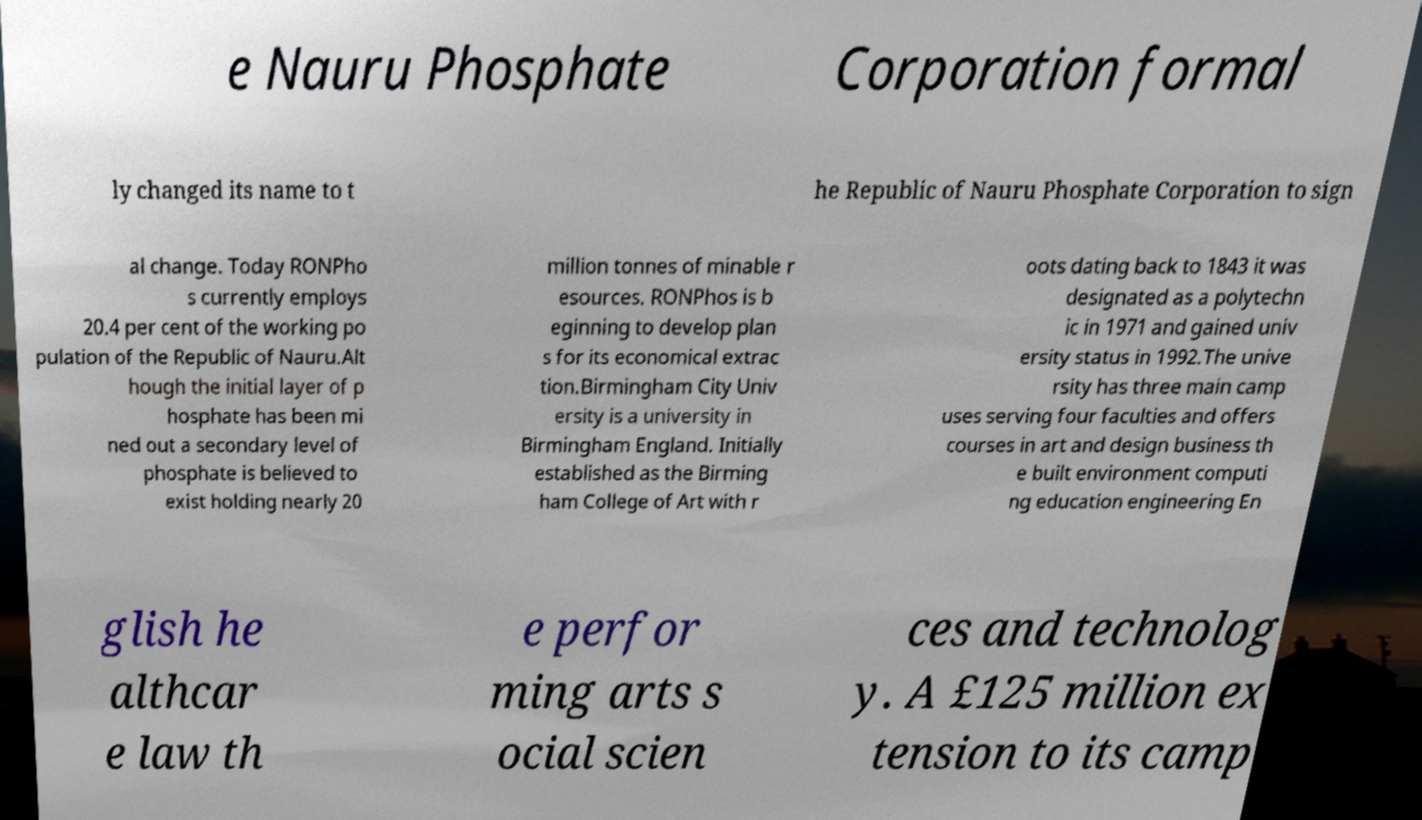Could you assist in decoding the text presented in this image and type it out clearly? e Nauru Phosphate Corporation formal ly changed its name to t he Republic of Nauru Phosphate Corporation to sign al change. Today RONPho s currently employs 20.4 per cent of the working po pulation of the Republic of Nauru.Alt hough the initial layer of p hosphate has been mi ned out a secondary level of phosphate is believed to exist holding nearly 20 million tonnes of minable r esources. RONPhos is b eginning to develop plan s for its economical extrac tion.Birmingham City Univ ersity is a university in Birmingham England. Initially established as the Birming ham College of Art with r oots dating back to 1843 it was designated as a polytechn ic in 1971 and gained univ ersity status in 1992.The unive rsity has three main camp uses serving four faculties and offers courses in art and design business th e built environment computi ng education engineering En glish he althcar e law th e perfor ming arts s ocial scien ces and technolog y. A £125 million ex tension to its camp 